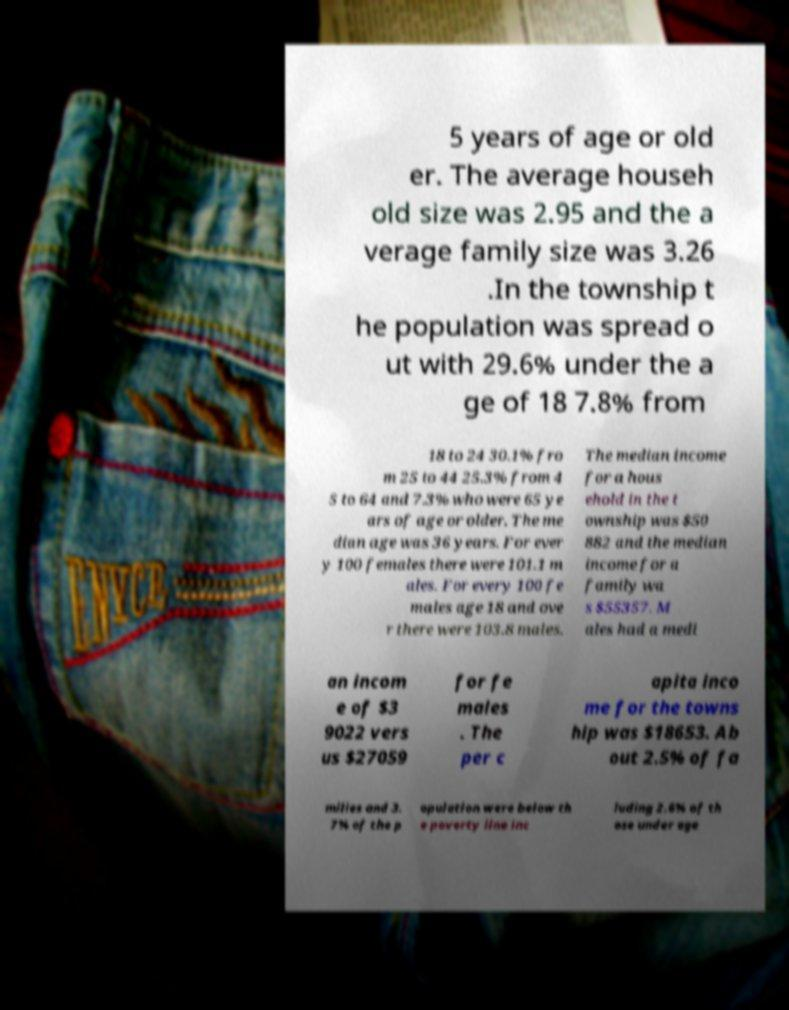Please identify and transcribe the text found in this image. 5 years of age or old er. The average househ old size was 2.95 and the a verage family size was 3.26 .In the township t he population was spread o ut with 29.6% under the a ge of 18 7.8% from 18 to 24 30.1% fro m 25 to 44 25.3% from 4 5 to 64 and 7.3% who were 65 ye ars of age or older. The me dian age was 36 years. For ever y 100 females there were 101.1 m ales. For every 100 fe males age 18 and ove r there were 103.8 males. The median income for a hous ehold in the t ownship was $50 882 and the median income for a family wa s $55357. M ales had a medi an incom e of $3 9022 vers us $27059 for fe males . The per c apita inco me for the towns hip was $18653. Ab out 2.5% of fa milies and 3. 7% of the p opulation were below th e poverty line inc luding 2.6% of th ose under age 